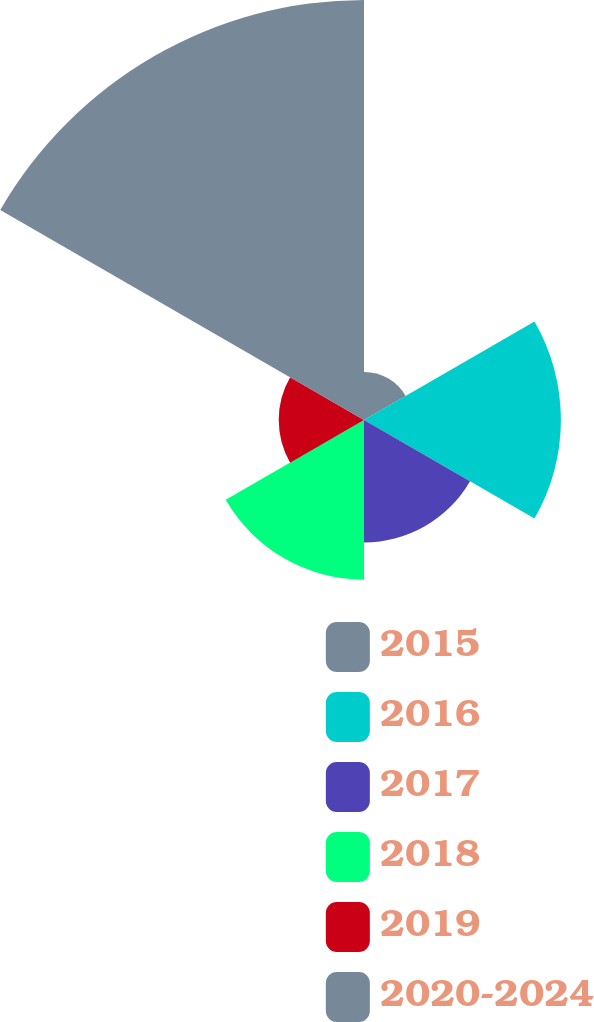<chart> <loc_0><loc_0><loc_500><loc_500><pie_chart><fcel>2015<fcel>2016<fcel>2017<fcel>2018<fcel>2019<fcel>2020-2024<nl><fcel>4.66%<fcel>19.07%<fcel>11.86%<fcel>15.47%<fcel>8.26%<fcel>40.68%<nl></chart> 